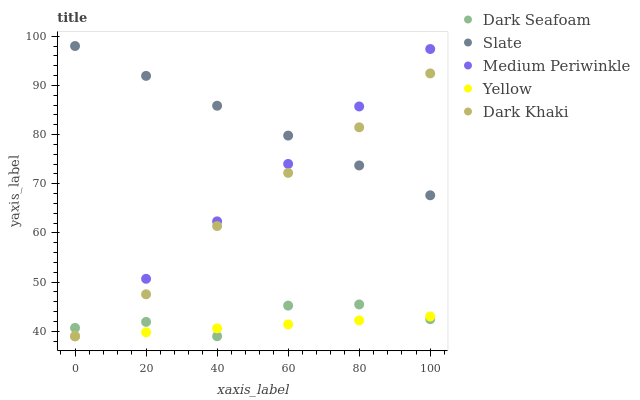Does Yellow have the minimum area under the curve?
Answer yes or no. Yes. Does Slate have the maximum area under the curve?
Answer yes or no. Yes. Does Dark Seafoam have the minimum area under the curve?
Answer yes or no. No. Does Dark Seafoam have the maximum area under the curve?
Answer yes or no. No. Is Slate the smoothest?
Answer yes or no. Yes. Is Dark Seafoam the roughest?
Answer yes or no. Yes. Is Medium Periwinkle the smoothest?
Answer yes or no. No. Is Medium Periwinkle the roughest?
Answer yes or no. No. Does Dark Khaki have the lowest value?
Answer yes or no. Yes. Does Slate have the lowest value?
Answer yes or no. No. Does Slate have the highest value?
Answer yes or no. Yes. Does Dark Seafoam have the highest value?
Answer yes or no. No. Is Dark Seafoam less than Slate?
Answer yes or no. Yes. Is Slate greater than Yellow?
Answer yes or no. Yes. Does Yellow intersect Dark Khaki?
Answer yes or no. Yes. Is Yellow less than Dark Khaki?
Answer yes or no. No. Is Yellow greater than Dark Khaki?
Answer yes or no. No. Does Dark Seafoam intersect Slate?
Answer yes or no. No. 